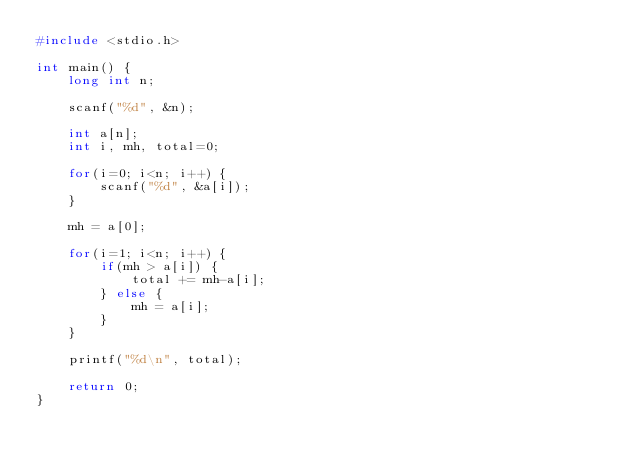<code> <loc_0><loc_0><loc_500><loc_500><_C_>#include <stdio.h>

int main() {
	long int n;

	scanf("%d", &n);

	int a[n];
	int i, mh, total=0;

	for(i=0; i<n; i++) {
		scanf("%d", &a[i]);
	}

	mh = a[0];

	for(i=1; i<n; i++) {
		if(mh > a[i]) {
			total += mh-a[i];
		} else {
			mh = a[i];
		}
	}

	printf("%d\n", total);

	return 0;
}
</code> 